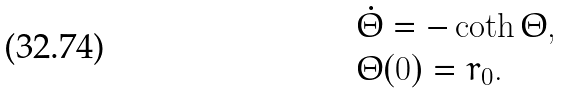Convert formula to latex. <formula><loc_0><loc_0><loc_500><loc_500>& \dot { \Theta } = - \coth \Theta , \\ & \Theta ( 0 ) = r _ { 0 } .</formula> 